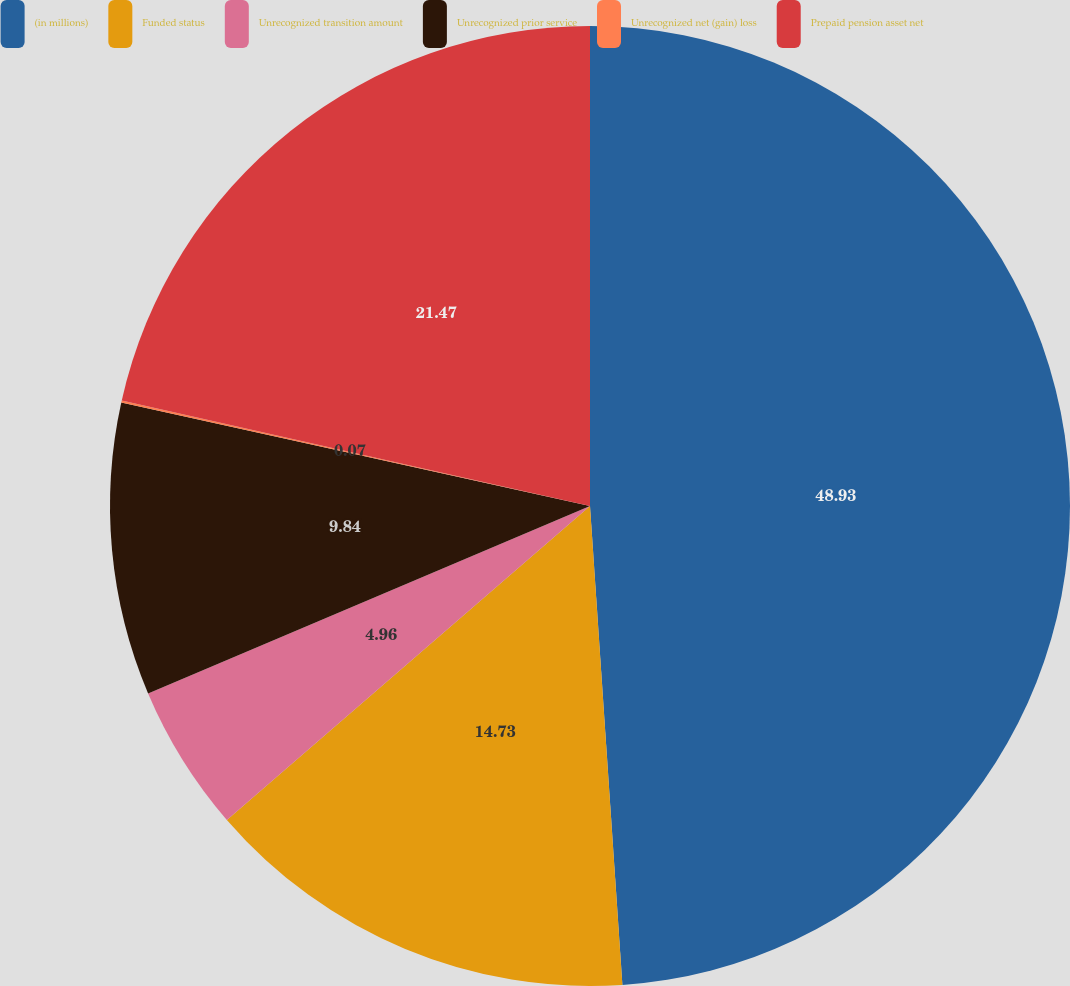Convert chart to OTSL. <chart><loc_0><loc_0><loc_500><loc_500><pie_chart><fcel>(in millions)<fcel>Funded status<fcel>Unrecognized transition amount<fcel>Unrecognized prior service<fcel>Unrecognized net (gain) loss<fcel>Prepaid pension asset net<nl><fcel>48.92%<fcel>14.73%<fcel>4.96%<fcel>9.84%<fcel>0.07%<fcel>21.47%<nl></chart> 